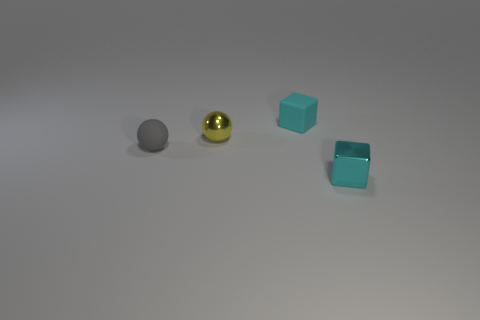Add 3 small cyan cubes. How many objects exist? 7 Subtract all small blue cylinders. Subtract all cyan rubber objects. How many objects are left? 3 Add 3 cyan objects. How many cyan objects are left? 5 Add 2 gray things. How many gray things exist? 3 Subtract 0 gray cylinders. How many objects are left? 4 